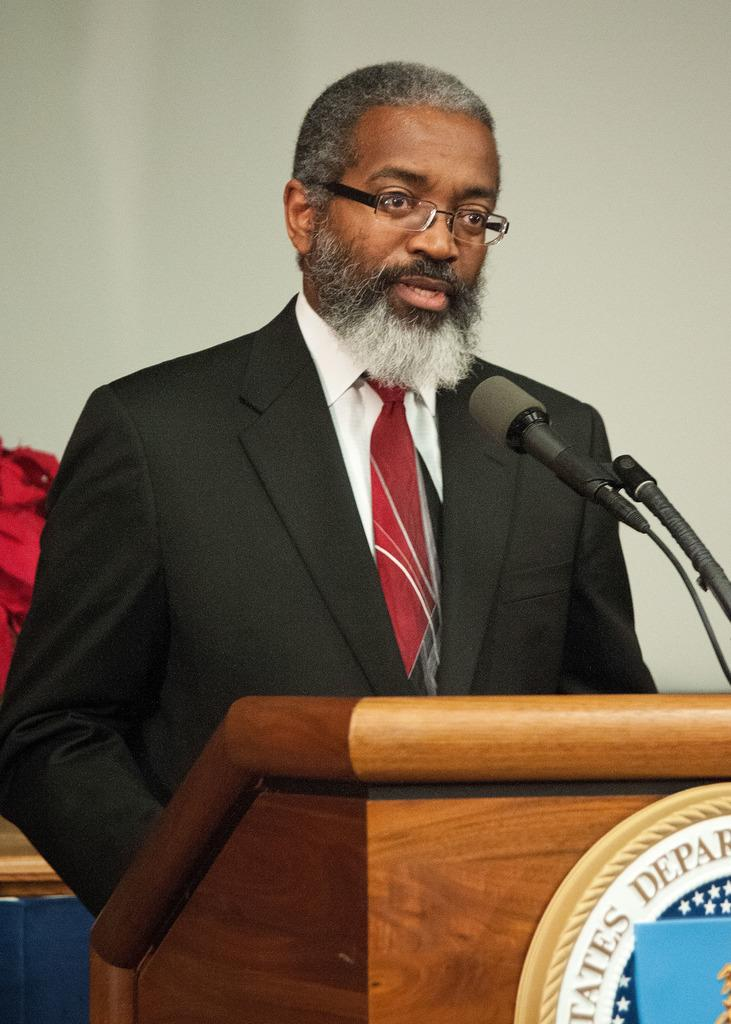Who is present in the image? There is a man in the image. What is the man doing in the image? The man is standing near a podium. What object is on the podium? There is a microphone on the podium. What can be seen behind the man? There is a wall behind the man. What type of invention is the man demonstrating in the image? There is no invention being demonstrated in the image; the man is simply standing near a podium with a microphone. What brand of toothpaste is the man using in the image? There is no toothpaste present in the image; it features a man standing near a podium with a microphone. 